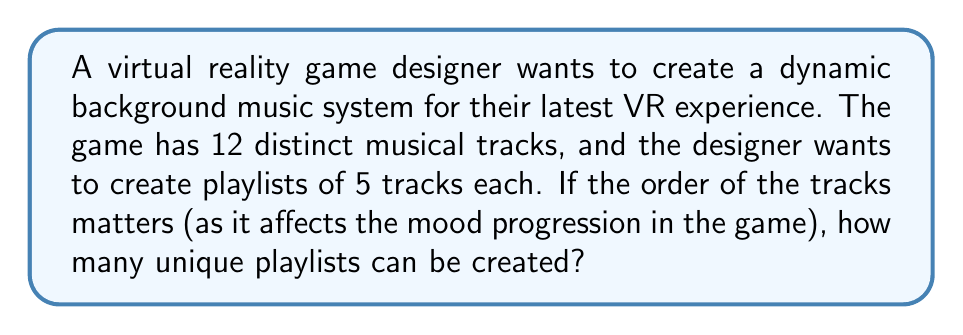Solve this math problem. To solve this problem, we need to use the concept of permutations. Here's why:

1. We are selecting 5 tracks out of 12 available tracks.
2. The order of selection matters, as it affects the mood progression in the game.
3. We are not repeating any tracks in a single playlist.

This scenario fits the formula for permutations without repetition:

$$P(n,r) = \frac{n!}{(n-r)!}$$

Where:
$n$ = total number of items to choose from (12 tracks)
$r$ = number of items being chosen (5 tracks in each playlist)

Let's plug in our values:

$$P(12,5) = \frac{12!}{(12-5)!} = \frac{12!}{7!}$$

Now, let's calculate this step-by-step:

1) Expand this:
   $$\frac{12 \times 11 \times 10 \times 9 \times 8 \times 7!}{7!}$$

2) The 7! cancels out in the numerator and denominator:
   $$12 \times 11 \times 10 \times 9 \times 8 = 95,040$$

Therefore, the number of unique playlists that can be created is 95,040.
Answer: 95,040 unique playlists 